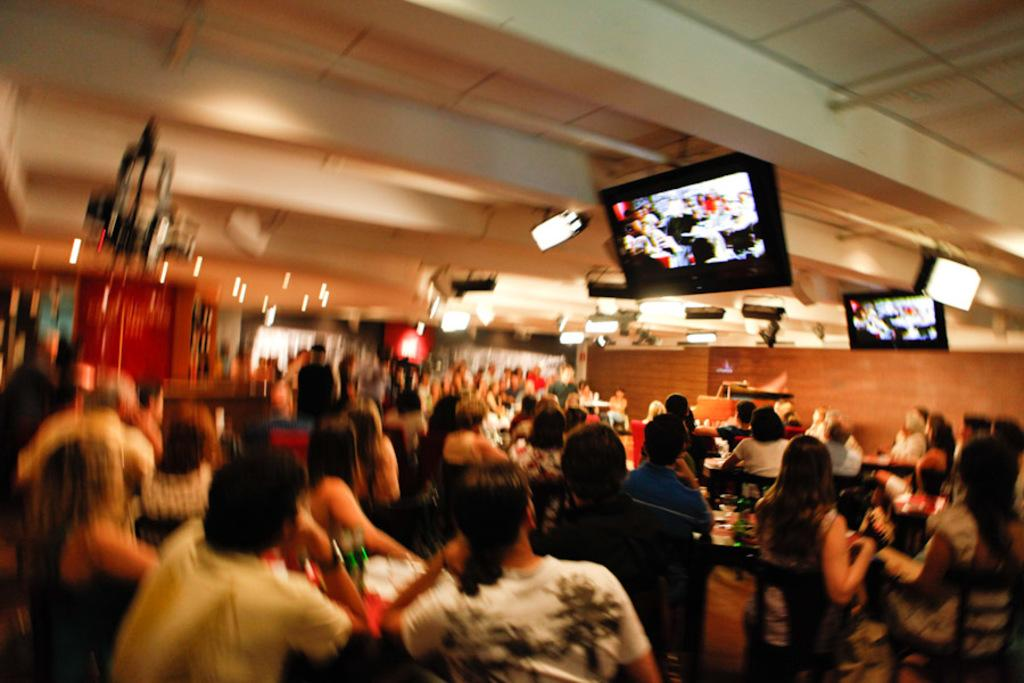How many people are in the image? There is a group of people in the image. What are the people doing in the image? The people are sitting on chairs. What can be seen in the image besides the people? There are lights visible in the image, as well as screens attached to the ceiling. What type of joke is being told by the person holding the quill in the image? There is no person holding a quill in the image, and no joke is being told. How does the drain affect the image quality? There is no drain present in the image, so it cannot affect the image quality. 